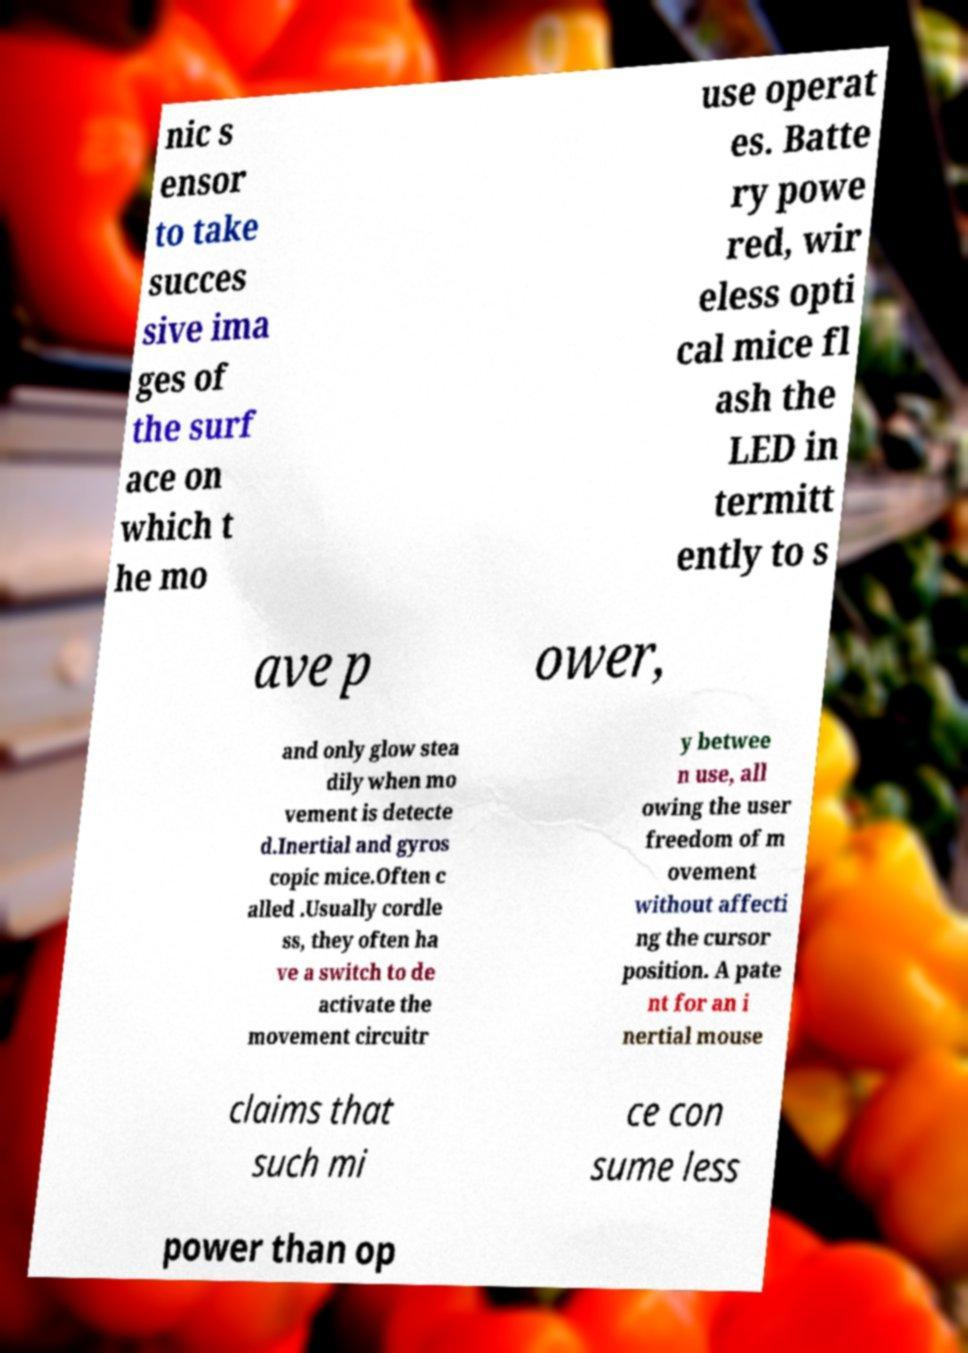For documentation purposes, I need the text within this image transcribed. Could you provide that? nic s ensor to take succes sive ima ges of the surf ace on which t he mo use operat es. Batte ry powe red, wir eless opti cal mice fl ash the LED in termitt ently to s ave p ower, and only glow stea dily when mo vement is detecte d.Inertial and gyros copic mice.Often c alled .Usually cordle ss, they often ha ve a switch to de activate the movement circuitr y betwee n use, all owing the user freedom of m ovement without affecti ng the cursor position. A pate nt for an i nertial mouse claims that such mi ce con sume less power than op 